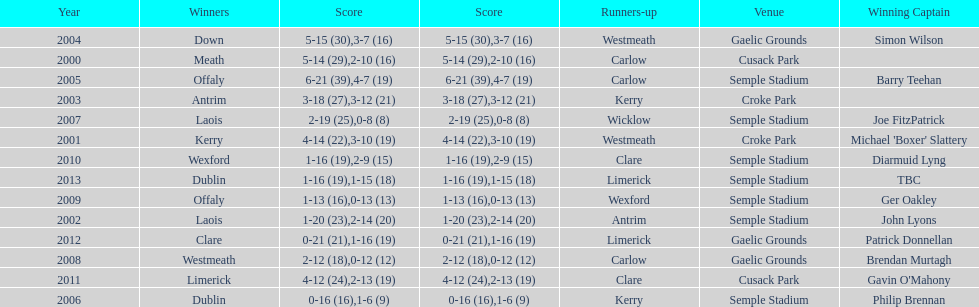What is the total number of times the competition was held at the semple stadium venue? 7. 